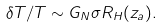Convert formula to latex. <formula><loc_0><loc_0><loc_500><loc_500>\delta T / T \sim G _ { N } \sigma R _ { H } ( z _ { a } ) .</formula> 